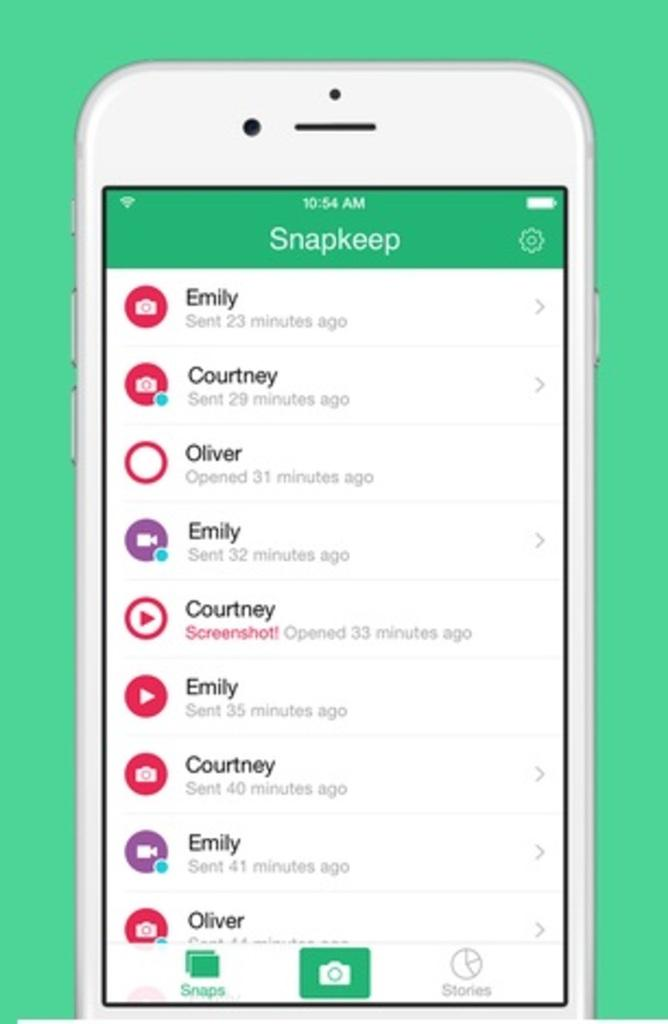<image>
Render a clear and concise summary of the photo. Emily, Courtney and Oliver are in a Snapkeep group. 